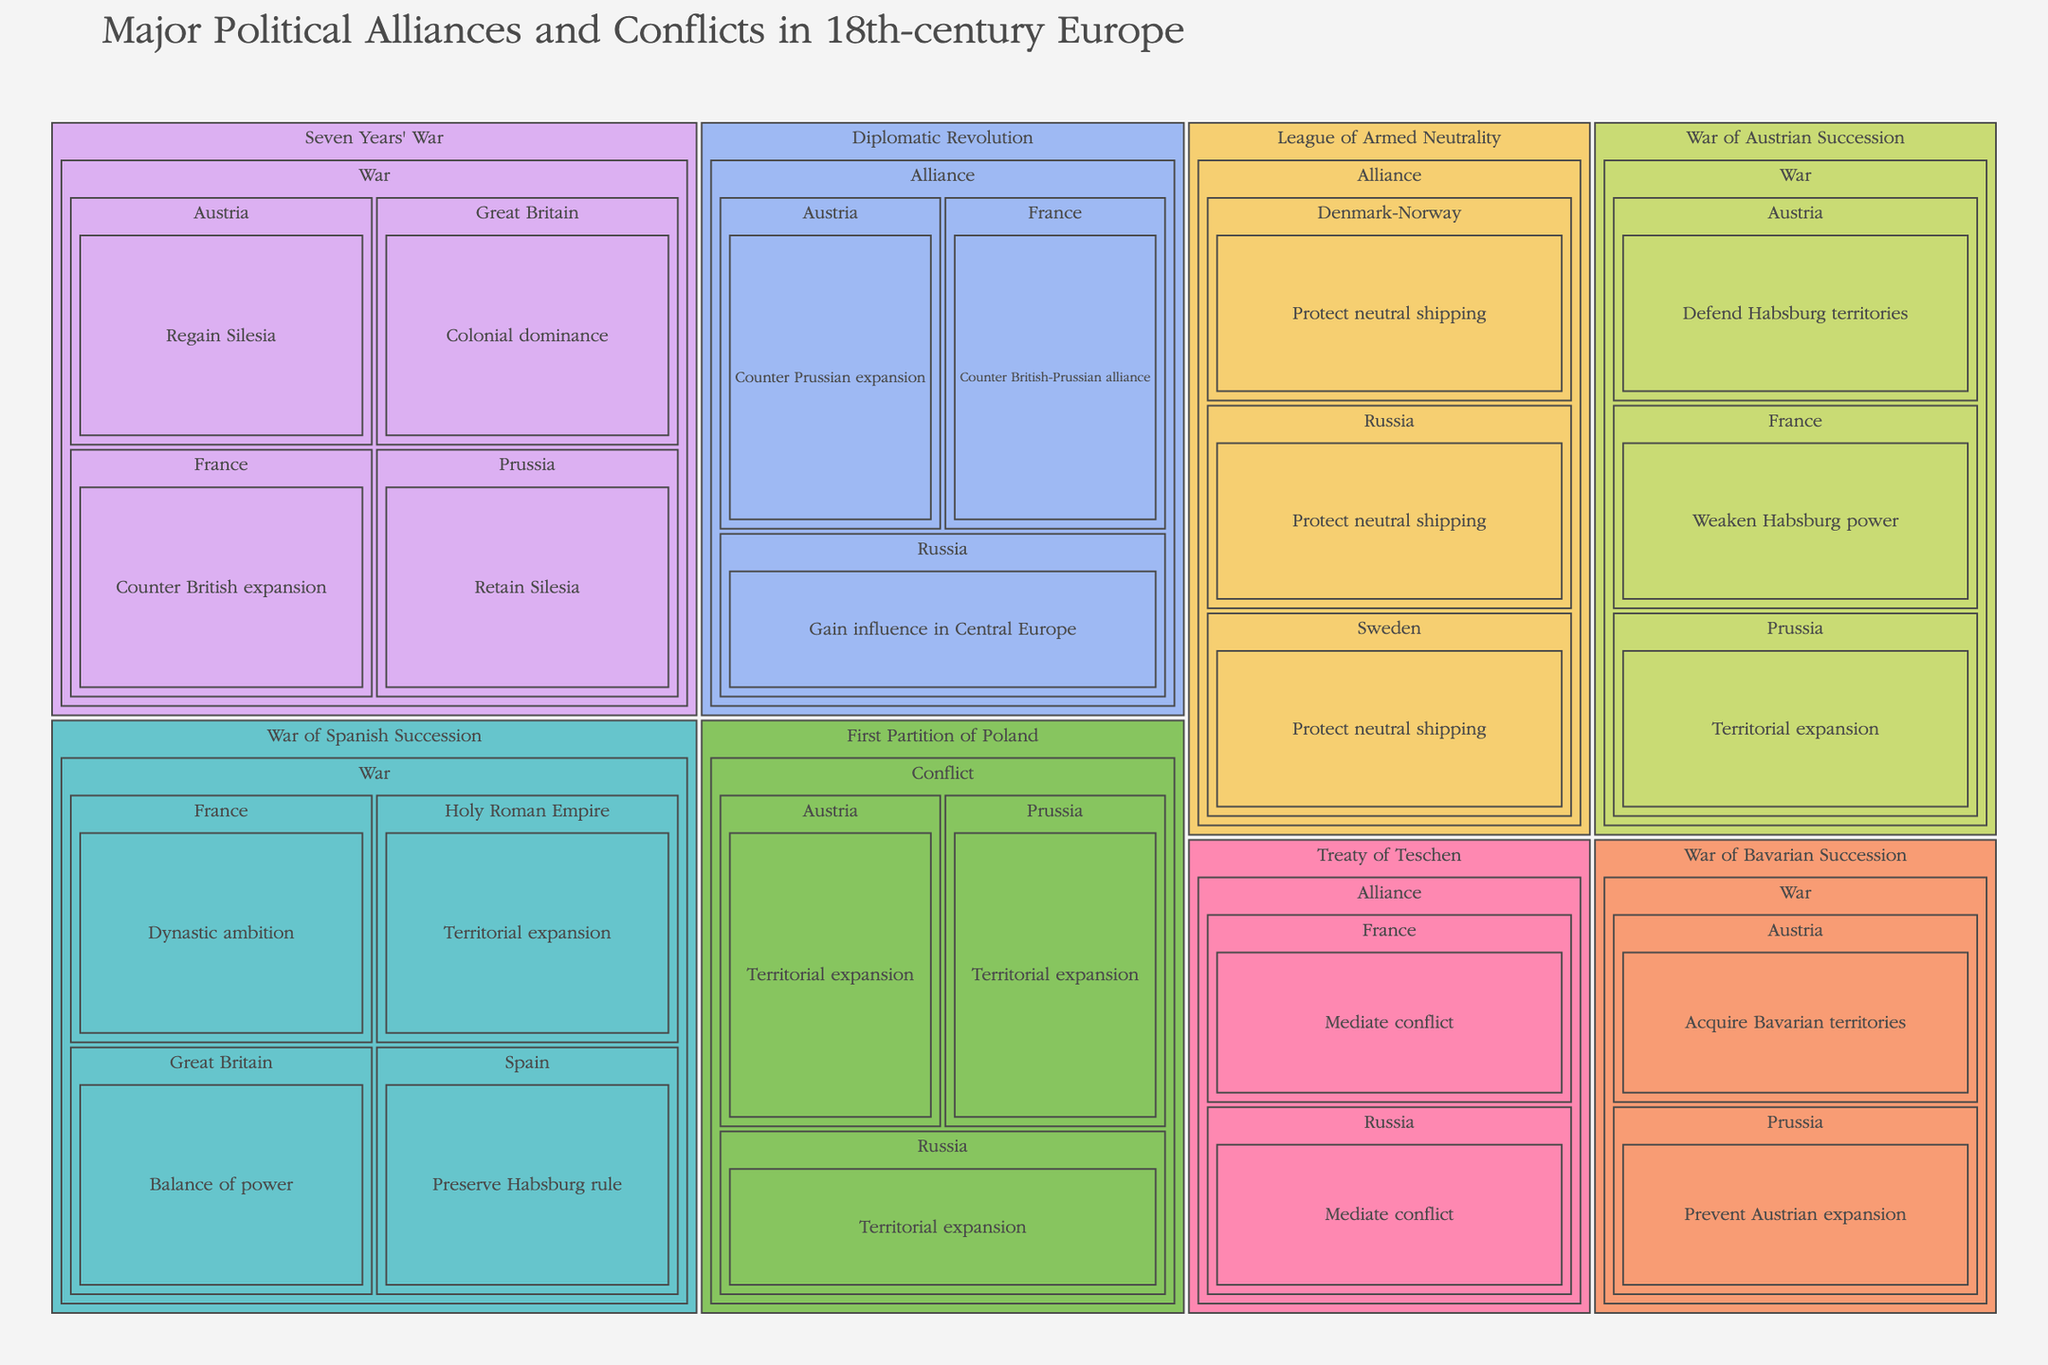What is the title of the treemap? The title is positioned at the top of the treemap and is usually written in a larger font size for emphasis.
Answer: Major Political Alliances and Conflicts in 18th-century Europe Which nation is involved in both the War of Spanish Succession and the Seven Years' War? By examining the categories and their subcategories, it is evident that the nation involved in both conflicts can be found under each war category.
Answer: France Which motivations are associated with Prussia in different conflicts? Look at each conflict category where Prussia is involved and list the motivations given in the subcategory of motivations.
Answer: Territorial expansion, Retain Silesia, Prevent Austrian expansion How many alliances and conflicts involve Austria? Count all instances where Austria is listed under either the Alliance or Conflict subcategories in the treemap.
Answer: Austria is involved in 6 alliances or conflicts What were the motivations for nations joining the Diplomatic Revolution? Identify the subcategory "Diplomatic Revolution" and list the detailed motivations for each nation involved.
Answer: Counter British-Prussian alliance (France), Counter Prussian expansion (Austria), Gain influence in Central Europe (Russia) Which conflict involved the most nations, and how many participated? Look at each conflict category and count the unique nations involved in each. Compare these counts to determine which conflict had the most nations participating.
Answer: The Seven Years' War involved 4 nations For which events did France and Russia both act as mediators? Identify all events under both Alliance and Conflict categories where both France and Russia are listed as participants with the motivation to mediate.
Answer: Treaty of Teschen How many categories contain both alliances and conflicts? Assess each primary category to determine if it has both "Alliance" and "Conflict" subcategories. Count the total number of such categories.
Answer: 0 categories. Each category is exclusively either an alliance or a conflict Which nation aimed to protect neutral shipping in the League of Armed Neutrality? Locate the subcategory "League of Armed Neutrality" and identify the nations involved and their motivations.
Answer: Russia, Denmark-Norway, Sweden How many times is territorial expansion listed as a motivation, and which nations had this motivation? Count the instances where "Territorial expansion" appears under the motivations across all conflicts. Identify the nations associated with this motivation.
Answer: Territorial expansion is listed 5 times by France, Holy Roman Empire, Prussia, Austria, and Russia 